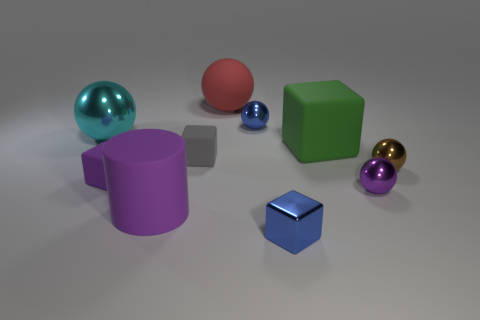Can you describe how light and shadow interact with the objects in the scene? Certainly! The scene is lit in such a way that each object casts a soft shadow on the ground, indicating a light source positioned above them. The shadows help enhance the three-dimensionality of the objects, and the shiny surfaces, like the blue cube, reflect light, adding a sense of realism to the composition. 